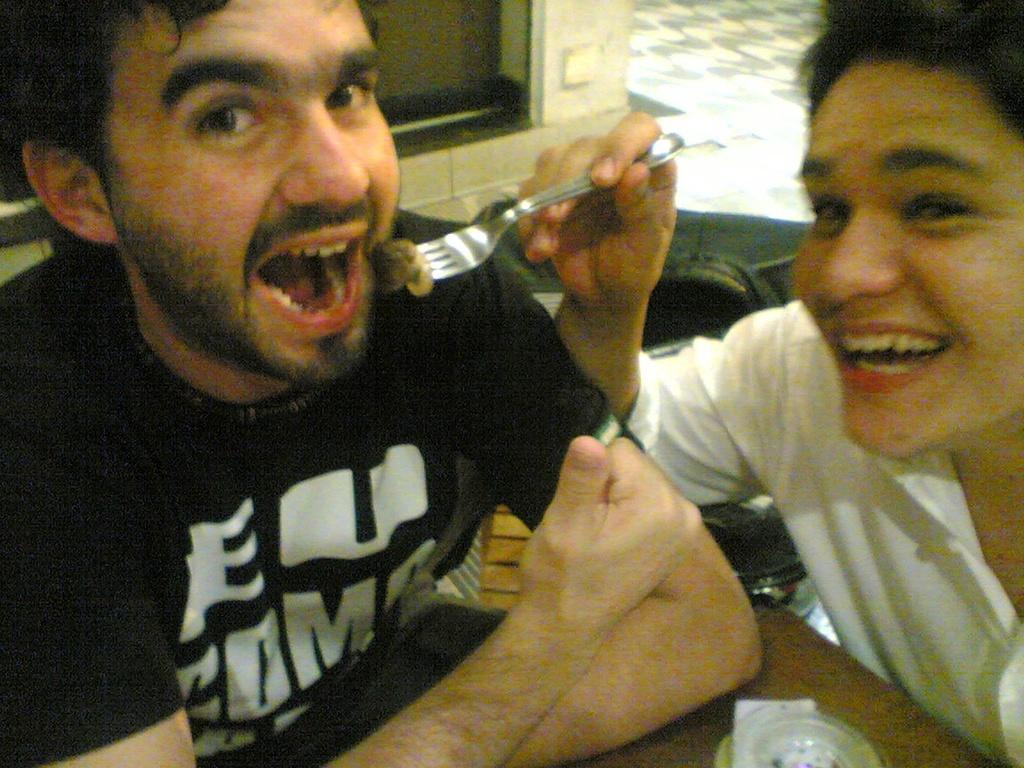In one or two sentences, can you explain what this image depicts? In this picture there is a boy wearing black t-shirt smiling and opening his mouth to eat the food. Beside there is a another boy wearing white shirt smiling and giving a pose into the camera by holding the fork. In the background we can see the glass window. 